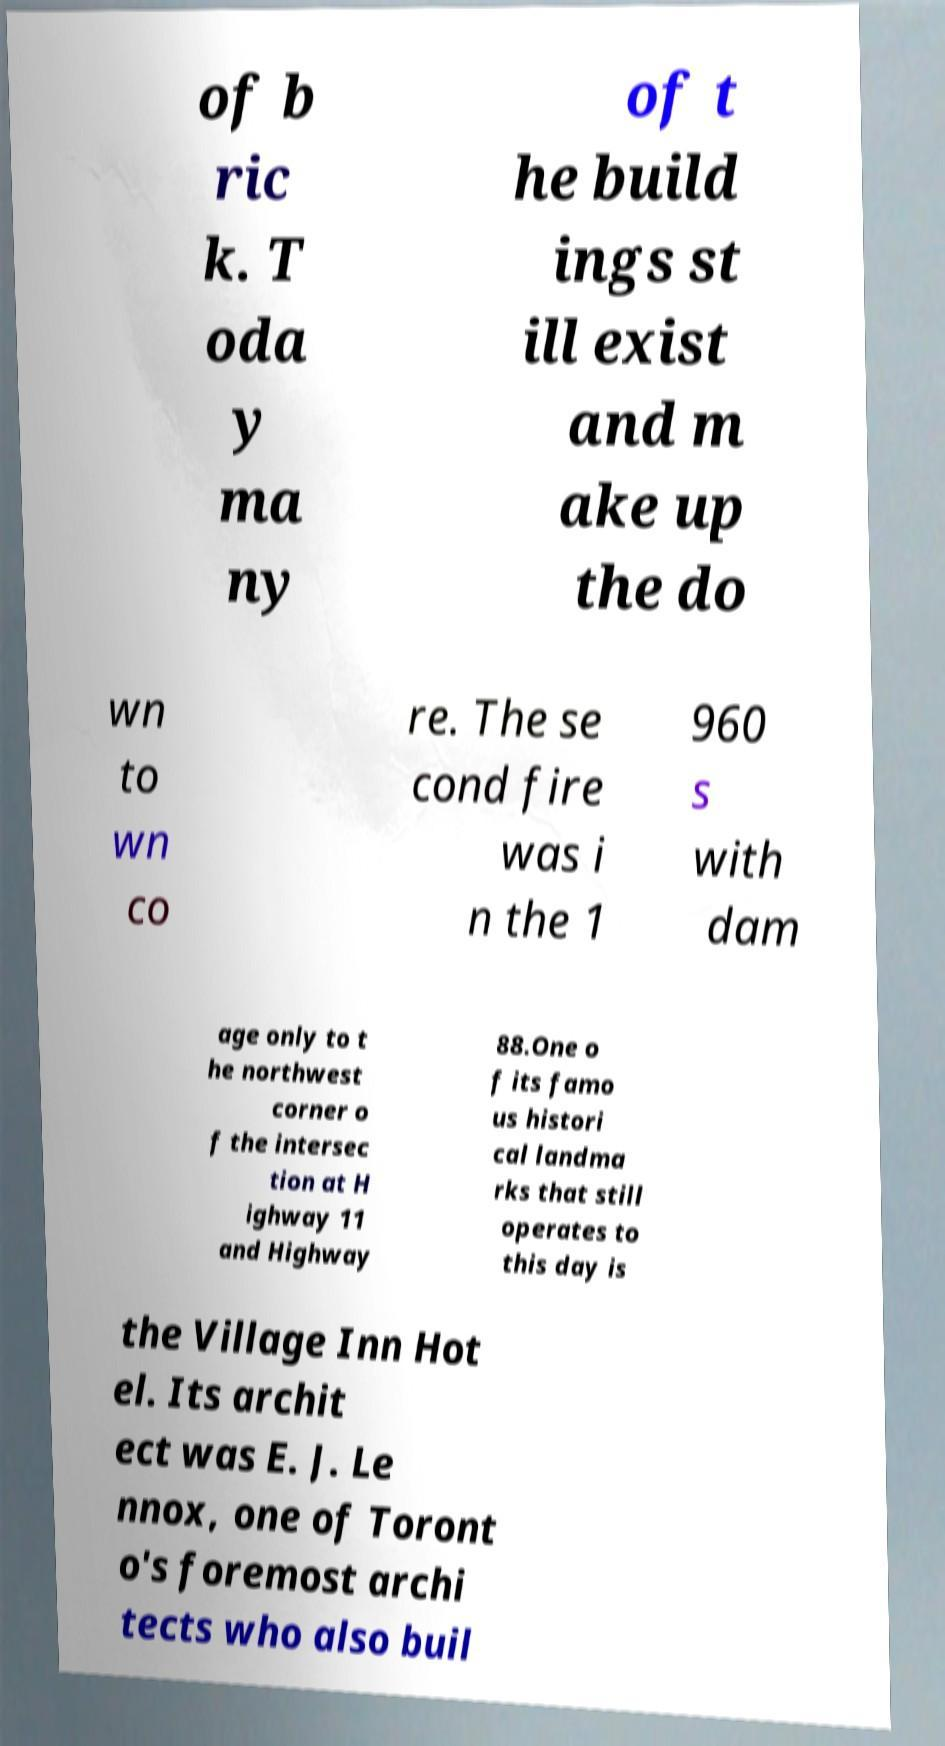Could you assist in decoding the text presented in this image and type it out clearly? of b ric k. T oda y ma ny of t he build ings st ill exist and m ake up the do wn to wn co re. The se cond fire was i n the 1 960 s with dam age only to t he northwest corner o f the intersec tion at H ighway 11 and Highway 88.One o f its famo us histori cal landma rks that still operates to this day is the Village Inn Hot el. Its archit ect was E. J. Le nnox, one of Toront o's foremost archi tects who also buil 